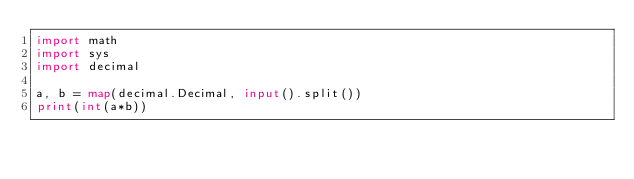<code> <loc_0><loc_0><loc_500><loc_500><_Python_>import math
import sys
import decimal

a, b = map(decimal.Decimal, input().split())
print(int(a*b))
</code> 